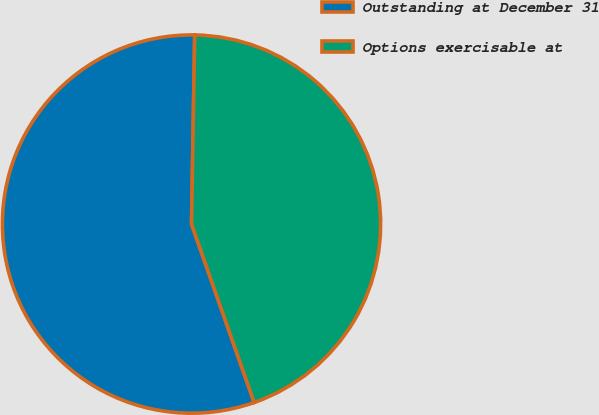Convert chart to OTSL. <chart><loc_0><loc_0><loc_500><loc_500><pie_chart><fcel>Outstanding at December 31<fcel>Options exercisable at<nl><fcel>55.64%<fcel>44.36%<nl></chart> 